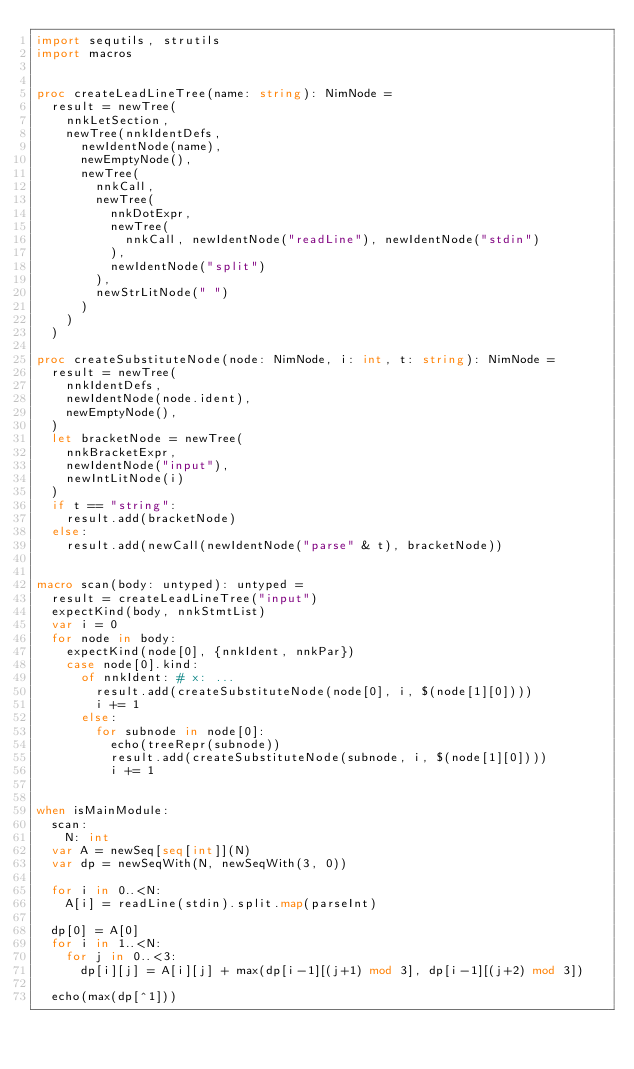<code> <loc_0><loc_0><loc_500><loc_500><_Nim_>import sequtils, strutils
import macros


proc createLeadLineTree(name: string): NimNode =
  result = newTree(
    nnkLetSection,
    newTree(nnkIdentDefs,
      newIdentNode(name),
      newEmptyNode(),
      newTree(
        nnkCall,
        newTree(
          nnkDotExpr,
          newTree(
            nnkCall, newIdentNode("readLine"), newIdentNode("stdin")
          ),
          newIdentNode("split")
        ),
        newStrLitNode(" ")
      )
    )
  )

proc createSubstituteNode(node: NimNode, i: int, t: string): NimNode =
  result = newTree(
    nnkIdentDefs, 
    newIdentNode(node.ident),
    newEmptyNode(),
  )
  let bracketNode = newTree(
    nnkBracketExpr,
    newIdentNode("input"),
    newIntLitNode(i)
  )
  if t == "string":
    result.add(bracketNode)
  else:
    result.add(newCall(newIdentNode("parse" & t), bracketNode))


macro scan(body: untyped): untyped =
  result = createLeadLineTree("input")
  expectKind(body, nnkStmtList)
  var i = 0
  for node in body:
    expectKind(node[0], {nnkIdent, nnkPar})
    case node[0].kind:
      of nnkIdent: # x: ...
        result.add(createSubstituteNode(node[0], i, $(node[1][0])))
        i += 1
      else:
        for subnode in node[0]:
          echo(treeRepr(subnode))
          result.add(createSubstituteNode(subnode, i, $(node[1][0])))
          i += 1


when isMainModule:
  scan:
    N: int
  var A = newSeq[seq[int]](N)
  var dp = newSeqWith(N, newSeqWith(3, 0))

  for i in 0..<N:
    A[i] = readLine(stdin).split.map(parseInt)

  dp[0] = A[0]
  for i in 1..<N:
    for j in 0..<3:
      dp[i][j] = A[i][j] + max(dp[i-1][(j+1) mod 3], dp[i-1][(j+2) mod 3])
  
  echo(max(dp[^1]))</code> 